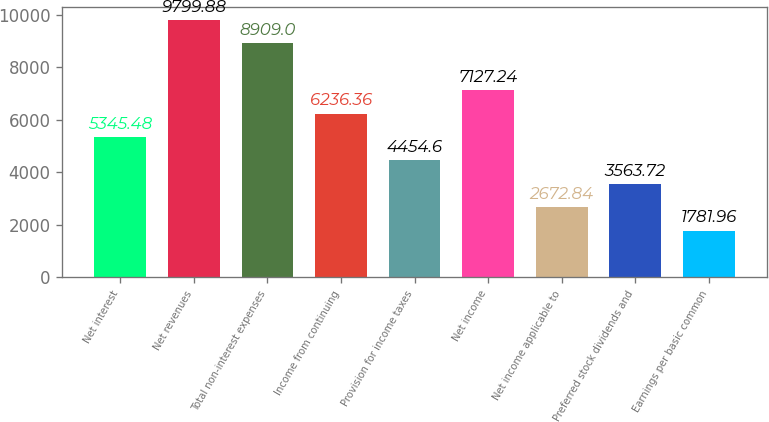<chart> <loc_0><loc_0><loc_500><loc_500><bar_chart><fcel>Net interest<fcel>Net revenues<fcel>Total non-interest expenses<fcel>Income from continuing<fcel>Provision for income taxes<fcel>Net income<fcel>Net income applicable to<fcel>Preferred stock dividends and<fcel>Earnings per basic common<nl><fcel>5345.48<fcel>9799.88<fcel>8909<fcel>6236.36<fcel>4454.6<fcel>7127.24<fcel>2672.84<fcel>3563.72<fcel>1781.96<nl></chart> 